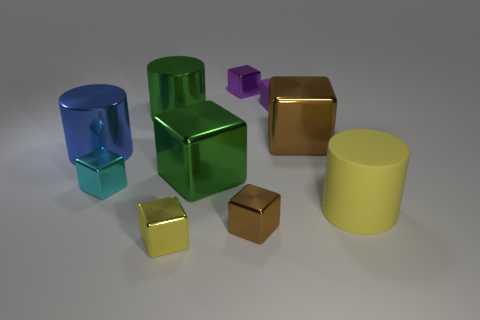Is the shape of the small cyan thing the same as the small brown shiny object in front of the large brown cube? yes 